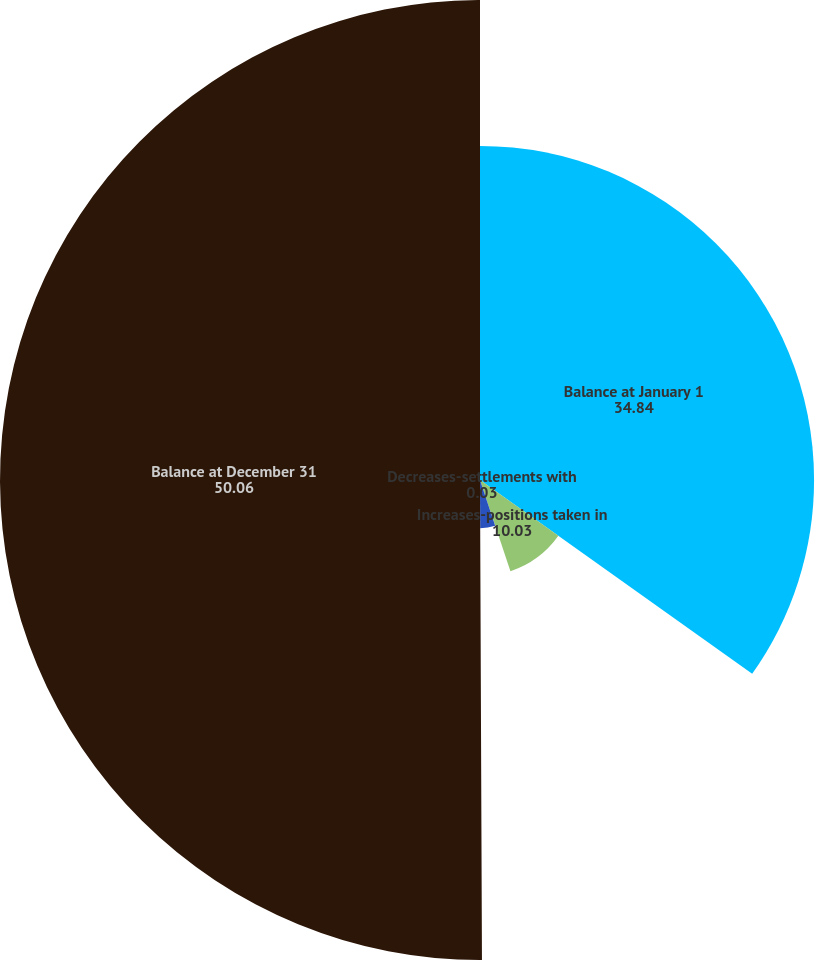Convert chart to OTSL. <chart><loc_0><loc_0><loc_500><loc_500><pie_chart><fcel>Balance at January 1<fcel>Increases-positions taken in<fcel>Decreases-settlements with<fcel>Decreases-lapse of applicable<fcel>Balance at December 31<nl><fcel>34.84%<fcel>10.03%<fcel>0.03%<fcel>5.03%<fcel>50.06%<nl></chart> 